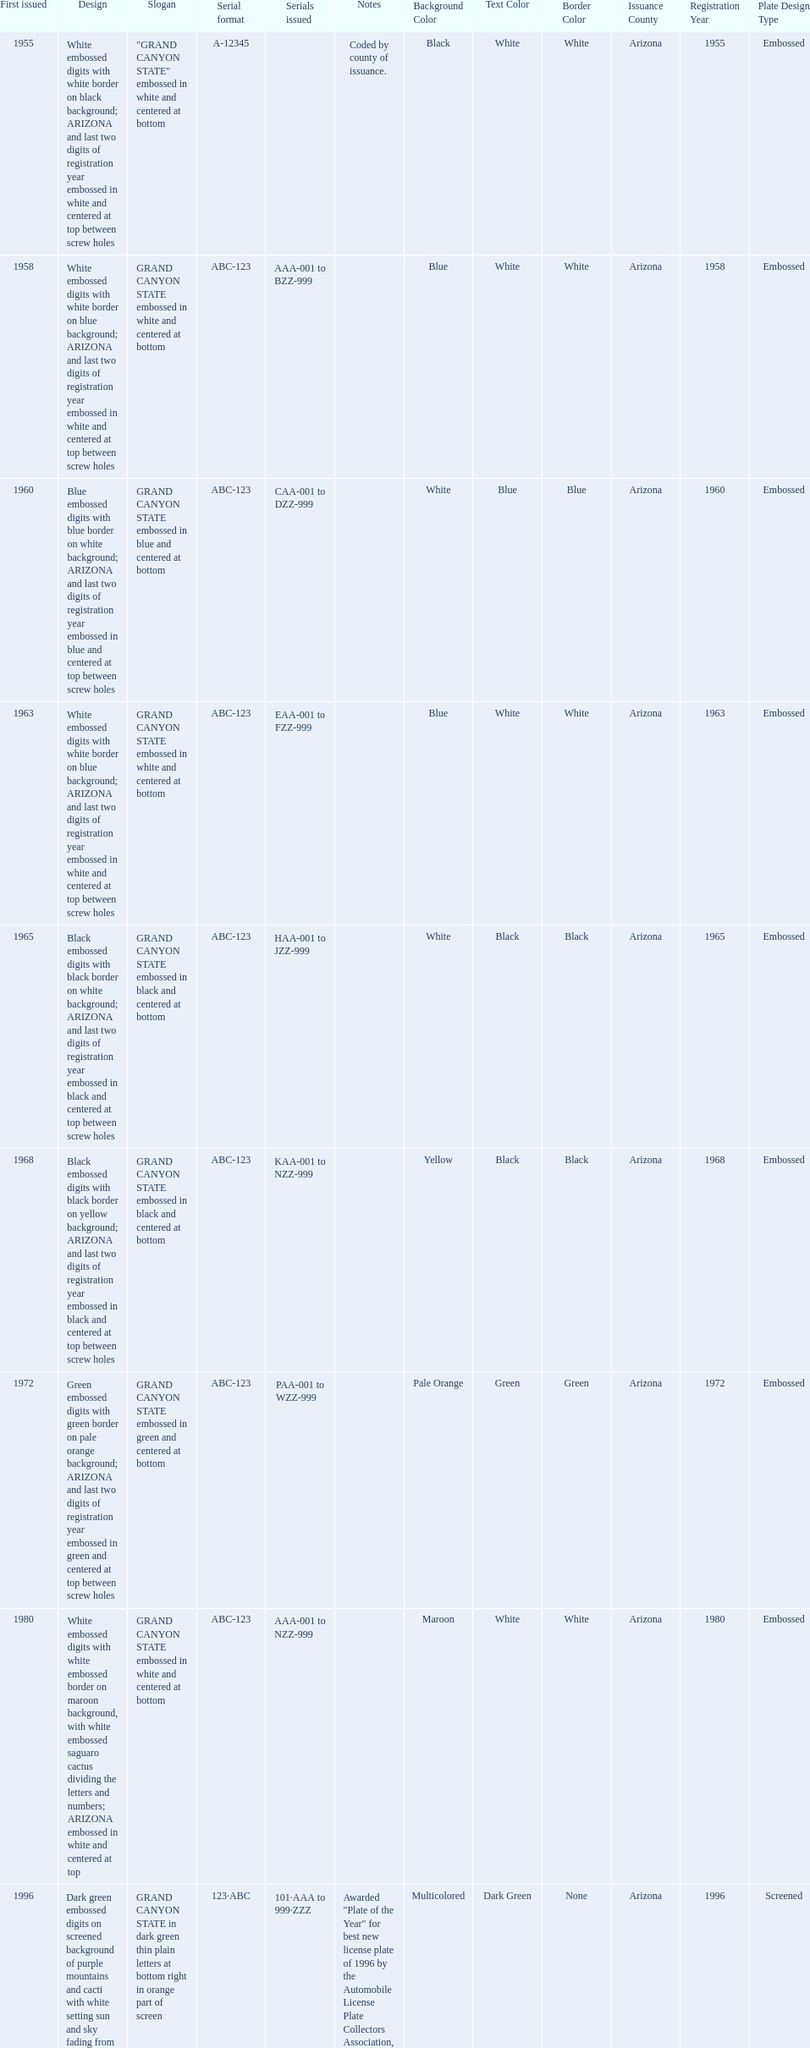In which year was the license plate with the maximum alphanumeric digits issued? 2008. 